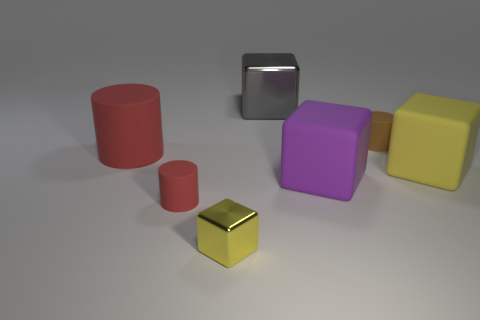What shape is the tiny rubber object that is the same color as the large rubber cylinder?
Ensure brevity in your answer.  Cylinder. How many tiny red objects are made of the same material as the tiny brown cylinder?
Provide a succinct answer. 1. There is a thing that is both to the left of the small yellow block and behind the small red cylinder; what shape is it?
Keep it short and to the point. Cylinder. Is the material of the big gray object that is behind the brown rubber object the same as the big purple thing?
Provide a succinct answer. No. Is there any other thing that has the same material as the small red cylinder?
Offer a very short reply. Yes. There is a block that is the same size as the brown rubber thing; what is its color?
Give a very brief answer. Yellow. Are there any tiny rubber things that have the same color as the big cylinder?
Keep it short and to the point. Yes. What is the size of the yellow cube that is the same material as the gray thing?
Give a very brief answer. Small. There is a rubber object that is the same color as the large cylinder; what size is it?
Provide a succinct answer. Small. What number of other objects are the same size as the brown cylinder?
Provide a succinct answer. 2. 